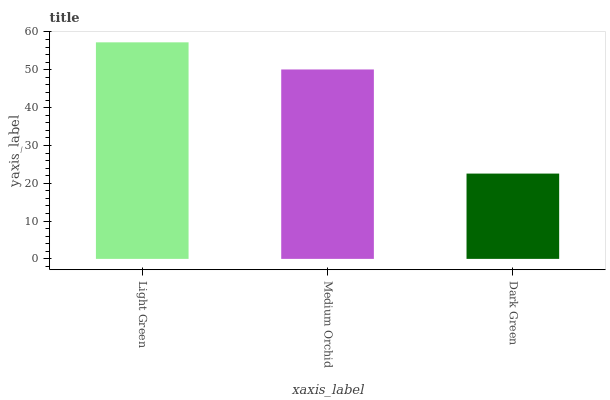Is Dark Green the minimum?
Answer yes or no. Yes. Is Light Green the maximum?
Answer yes or no. Yes. Is Medium Orchid the minimum?
Answer yes or no. No. Is Medium Orchid the maximum?
Answer yes or no. No. Is Light Green greater than Medium Orchid?
Answer yes or no. Yes. Is Medium Orchid less than Light Green?
Answer yes or no. Yes. Is Medium Orchid greater than Light Green?
Answer yes or no. No. Is Light Green less than Medium Orchid?
Answer yes or no. No. Is Medium Orchid the high median?
Answer yes or no. Yes. Is Medium Orchid the low median?
Answer yes or no. Yes. Is Light Green the high median?
Answer yes or no. No. Is Light Green the low median?
Answer yes or no. No. 